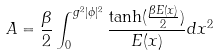<formula> <loc_0><loc_0><loc_500><loc_500>A = \frac { \beta } { 2 } \int _ { 0 } ^ { g ^ { 2 } | \phi | ^ { 2 } } \frac { \tanh ( \frac { \beta E ( x ) } { 2 } ) } { E ( x ) } d x ^ { 2 }</formula> 